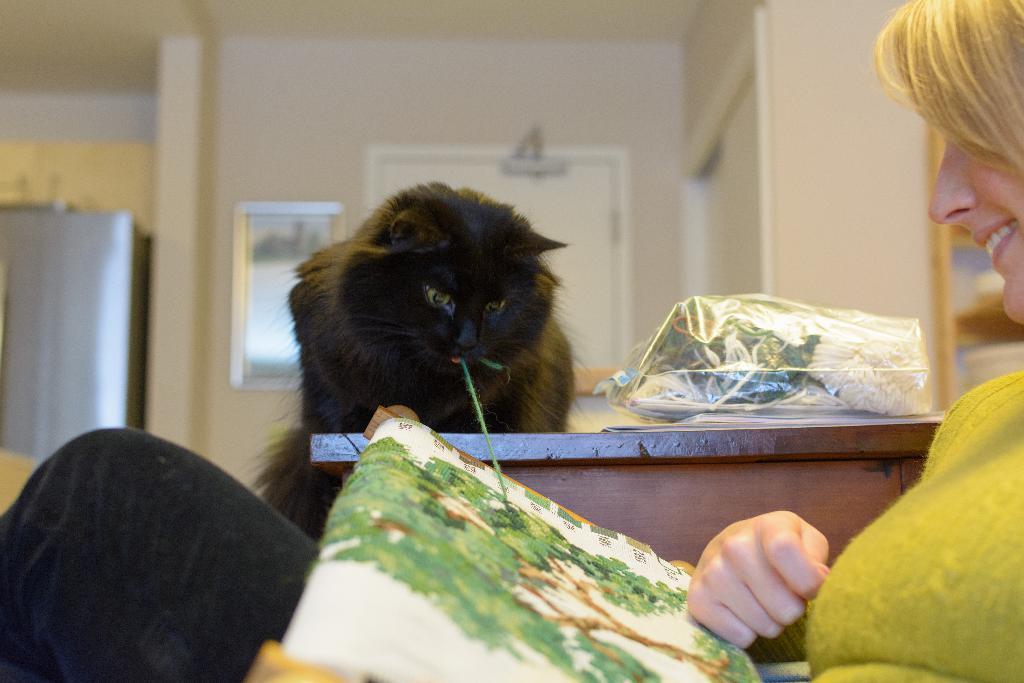Can you describe this image briefly? In this picture there is a black cat were sitting on the table. Beside the cat I can see some cloth in a plastic cover. On the right there is a woman who is wearing t-shirt and trouser. She is holding the cloth and she is smiling. In the back I can see the mirror near to the door. 